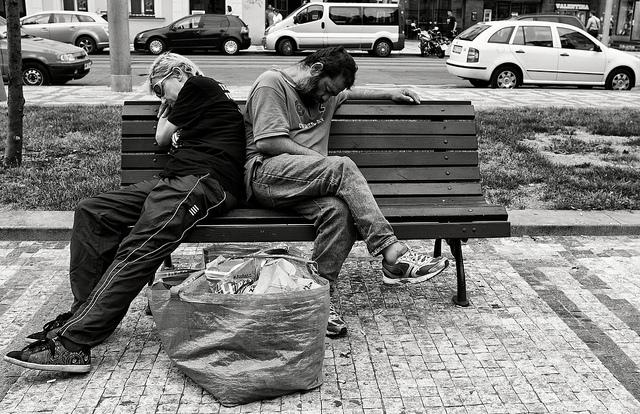What vehicle on the north side of the street will the car traveling west pass second? black car 